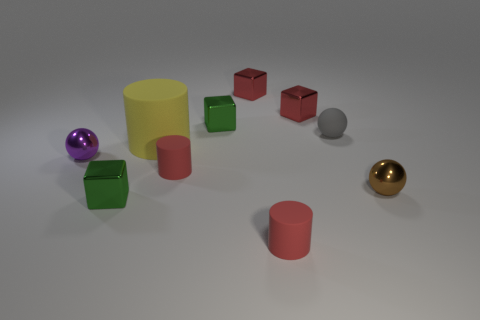How many objects are there in total in the image? In total, there are nine objects in the image, consisting of a collection of geometric shapes and including various colors and materials. 